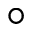Convert formula to latex. <formula><loc_0><loc_0><loc_500><loc_500>^ { \circ }</formula> 